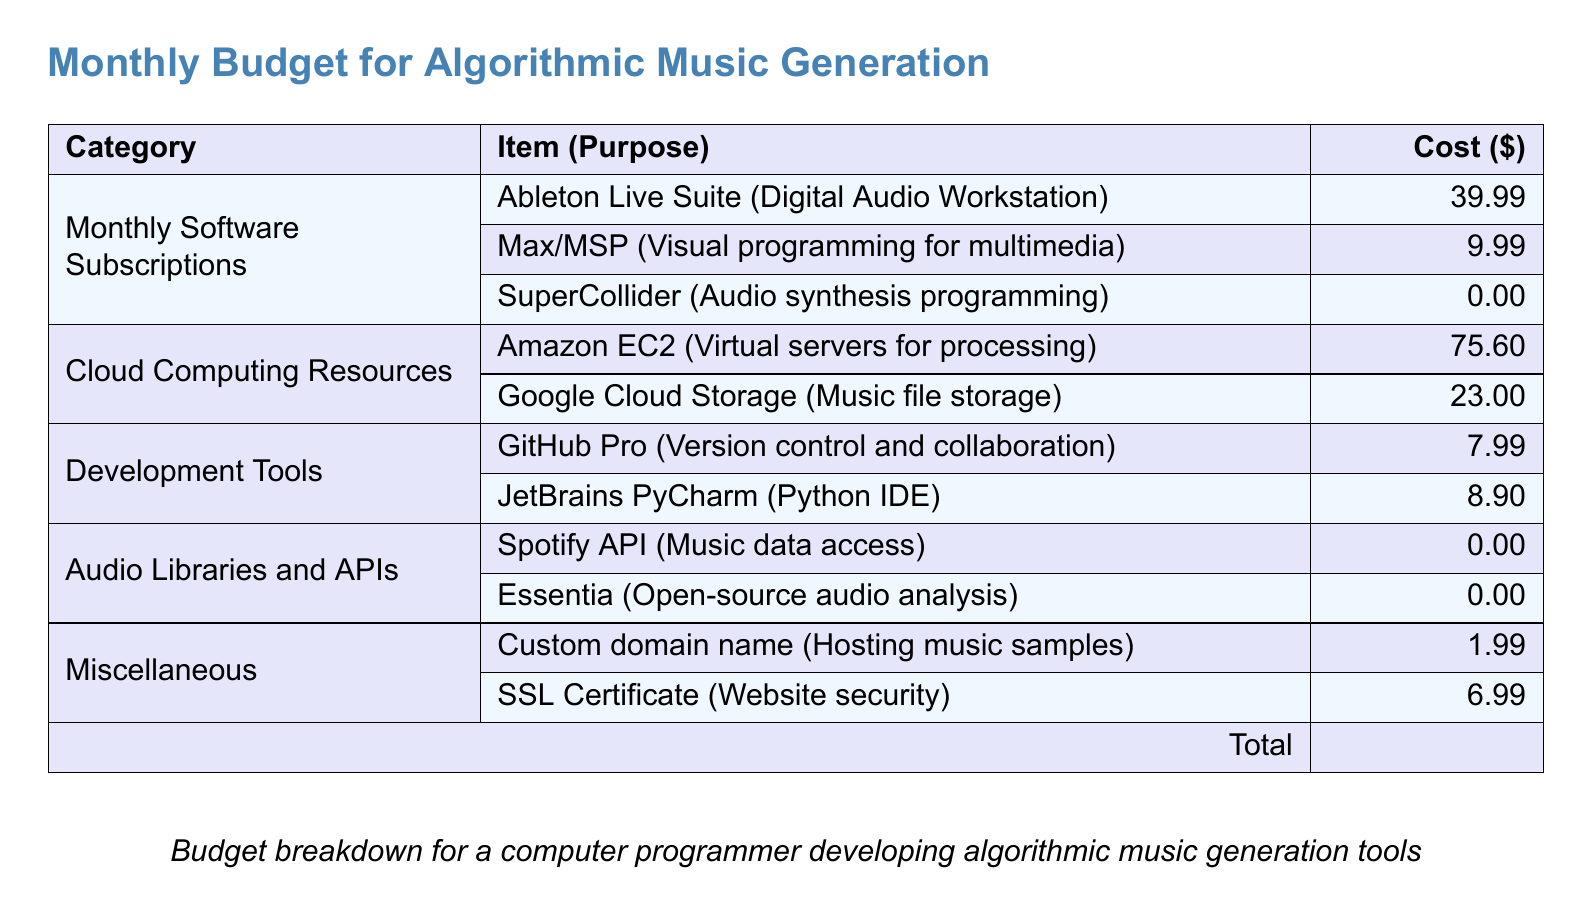what is the total cost for the software subscriptions? The total cost is the sum of Ableton Live Suite, Max/MSP, and SuperCollider, which is $39.99 + $9.99 + $0.00 = $49.98.
Answer: $49.98 how much does Amazon EC2 cost? The cost of Amazon EC2, which is a virtual server for processing, is specifically listed at $75.60.
Answer: $75.60 which item is listed under development tools? The document includes GitHub Pro as a version control and collaboration tool under development tools.
Answer: GitHub Pro what is the cost of the custom domain name? The document states that the cost of a custom domain name for hosting music samples is $1.99.
Answer: $1.99 how many items are listed under audio libraries and APIs? The document shows two items listed under audio libraries and APIs: Spotify API and Essentia.
Answer: 2 what is the total budget amount? The document provides the total budget amount, which is the sum of all costs listed, as $174.45.
Answer: $174.45 which cloud computing resource has the lowest cost? The cost of Google Cloud Storage, at $23.00, is noted as the lowest among the listed cloud computing resources.
Answer: Google Cloud Storage what type of document is this? The document is a budget plan detailing monthly expenses for software subscriptions and cloud computing resources used in algorithmic music generation.
Answer: Budget 